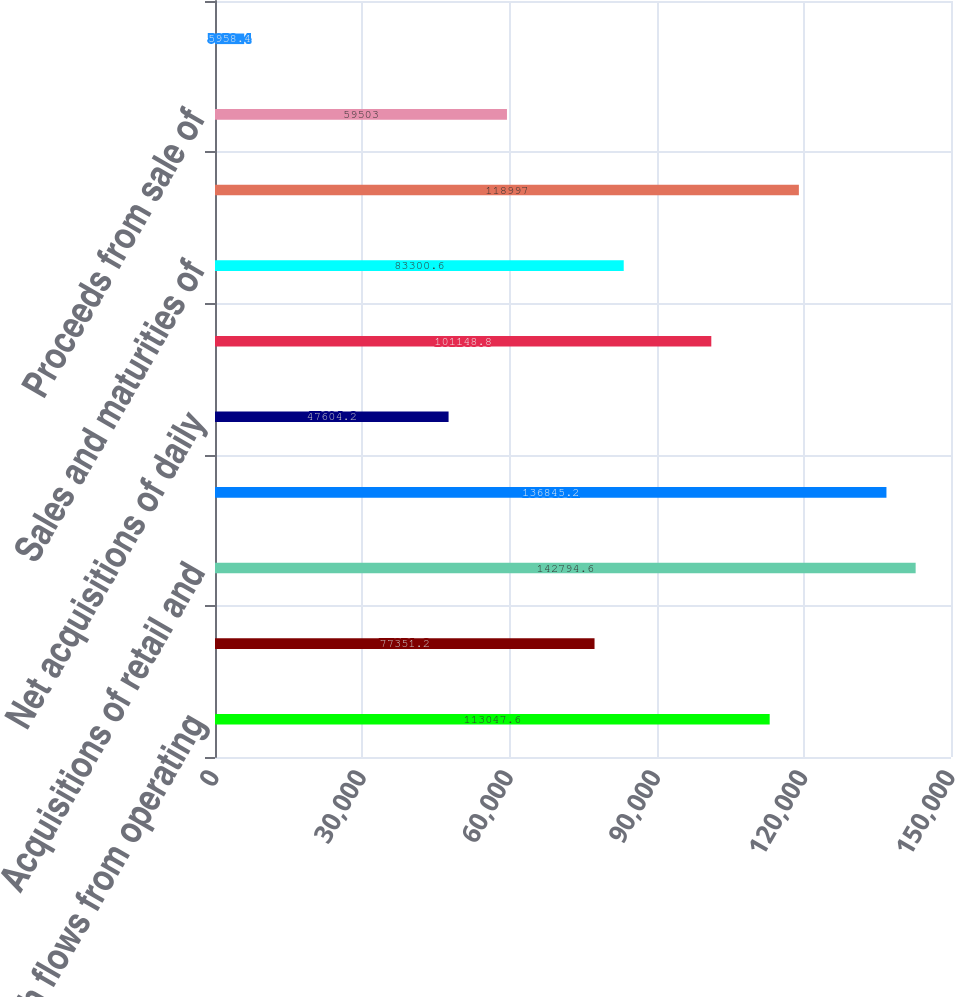Convert chart. <chart><loc_0><loc_0><loc_500><loc_500><bar_chart><fcel>Net cash flows from operating<fcel>Capital expenditures<fcel>Acquisitions of retail and<fcel>Collections of retail and<fcel>Net acquisitions of daily<fcel>Purchases of securities<fcel>Sales and maturities of<fcel>Proceeds from sales of retail<fcel>Proceeds from sale of<fcel>Transfer of cash balances upon<nl><fcel>113048<fcel>77351.2<fcel>142795<fcel>136845<fcel>47604.2<fcel>101149<fcel>83300.6<fcel>118997<fcel>59503<fcel>5958.4<nl></chart> 